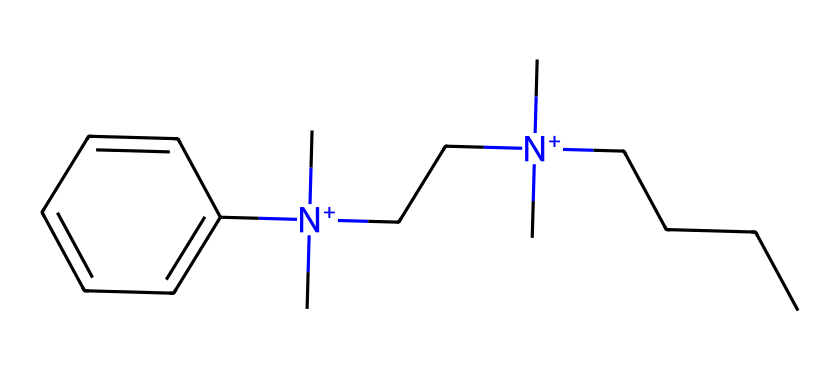What is the molecular formula of this compound? To find the molecular formula, we count the number of each type of atom present in the SMILES representation. In the provided SMILES, we can identify carbon (C), nitrogen (N), and hydrogen (H) atoms. The chemical contains 20 carbon atoms, 2 nitrogen atoms, and 36 hydrogen atoms, leading to the formula C20H36N2.
Answer: C20H36N2 How many nitrogen atoms are present in the compound? By examining the SMILES representation, we can see that there are two occurrences of nitrogen, which are represented by the [N+] symbols in the structure.
Answer: 2 What type of functional groups are present in this chemical? The SMILES indicates the presence of amine groups due to the nitrogen atoms and suggests a quaternary ammonium compound because of the positively charged nitrogen atoms. These features indicate typical functional groups found in surfactants.
Answer: amine How many carbon chains are in the molecule? In the SMILES, we notice carbon chains that are connected and branched, and the presence of a long hydrocarbon chain of 9 carbon atoms. There are also branched methyl groups attached to the nitrogen atoms. Counting these gives us a total of 12 carbon chains in different structural contributions.
Answer: 12 What structural feature allows this compound to function as a disinfectant? The presence of long hydrocarbon chains along with the quaternary ammonium nitrogen atoms contribute to its amphiphilic nature. The hydrophobic (water-repelling) carbon chains facilitate interaction with microbial membranes, while the polar, positively charged nitrogen allows for solubility in aqueous environments, making it effective as a disinfectant.
Answer: amphiphilic nature What is the significance of the quaternary nitrogen in this compound? The quaternary nitrogen provides a positive charge, which enhances the molecule's ability to adhere to negatively charged surfaces, such as microbial cell membranes. This charge is crucial for the disinfectant properties, allowing it to disrupt microbial layers effectively.
Answer: positive charge 